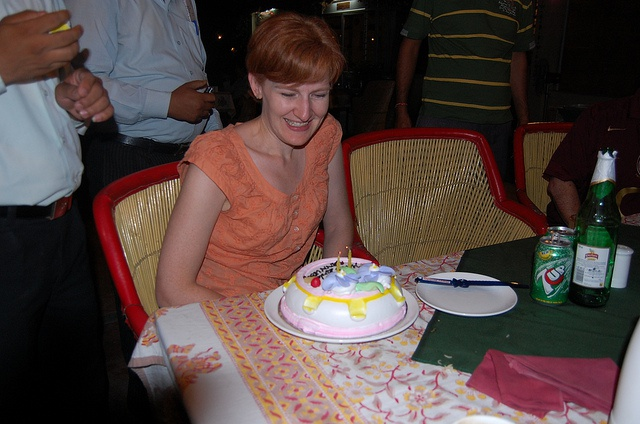Describe the objects in this image and their specific colors. I can see dining table in gray, black, darkgray, lavender, and brown tones, people in gray, black, darkgray, and maroon tones, people in gray, brown, and maroon tones, chair in gray, olive, maroon, and black tones, and people in gray, black, and maroon tones in this image. 